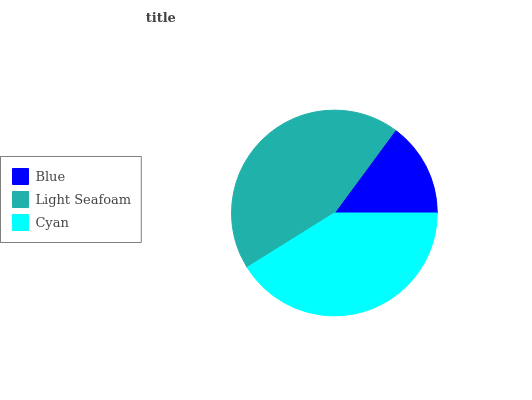Is Blue the minimum?
Answer yes or no. Yes. Is Light Seafoam the maximum?
Answer yes or no. Yes. Is Cyan the minimum?
Answer yes or no. No. Is Cyan the maximum?
Answer yes or no. No. Is Light Seafoam greater than Cyan?
Answer yes or no. Yes. Is Cyan less than Light Seafoam?
Answer yes or no. Yes. Is Cyan greater than Light Seafoam?
Answer yes or no. No. Is Light Seafoam less than Cyan?
Answer yes or no. No. Is Cyan the high median?
Answer yes or no. Yes. Is Cyan the low median?
Answer yes or no. Yes. Is Light Seafoam the high median?
Answer yes or no. No. Is Blue the low median?
Answer yes or no. No. 